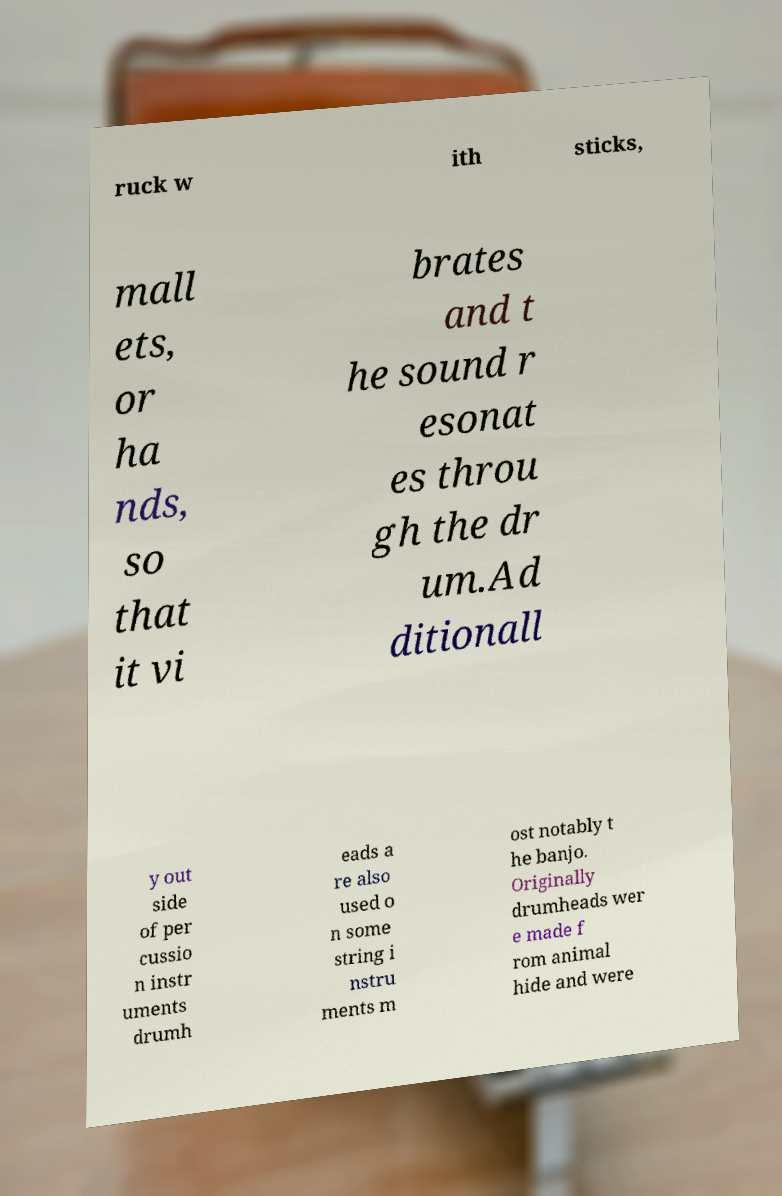Please identify and transcribe the text found in this image. ruck w ith sticks, mall ets, or ha nds, so that it vi brates and t he sound r esonat es throu gh the dr um.Ad ditionall y out side of per cussio n instr uments drumh eads a re also used o n some string i nstru ments m ost notably t he banjo. Originally drumheads wer e made f rom animal hide and were 